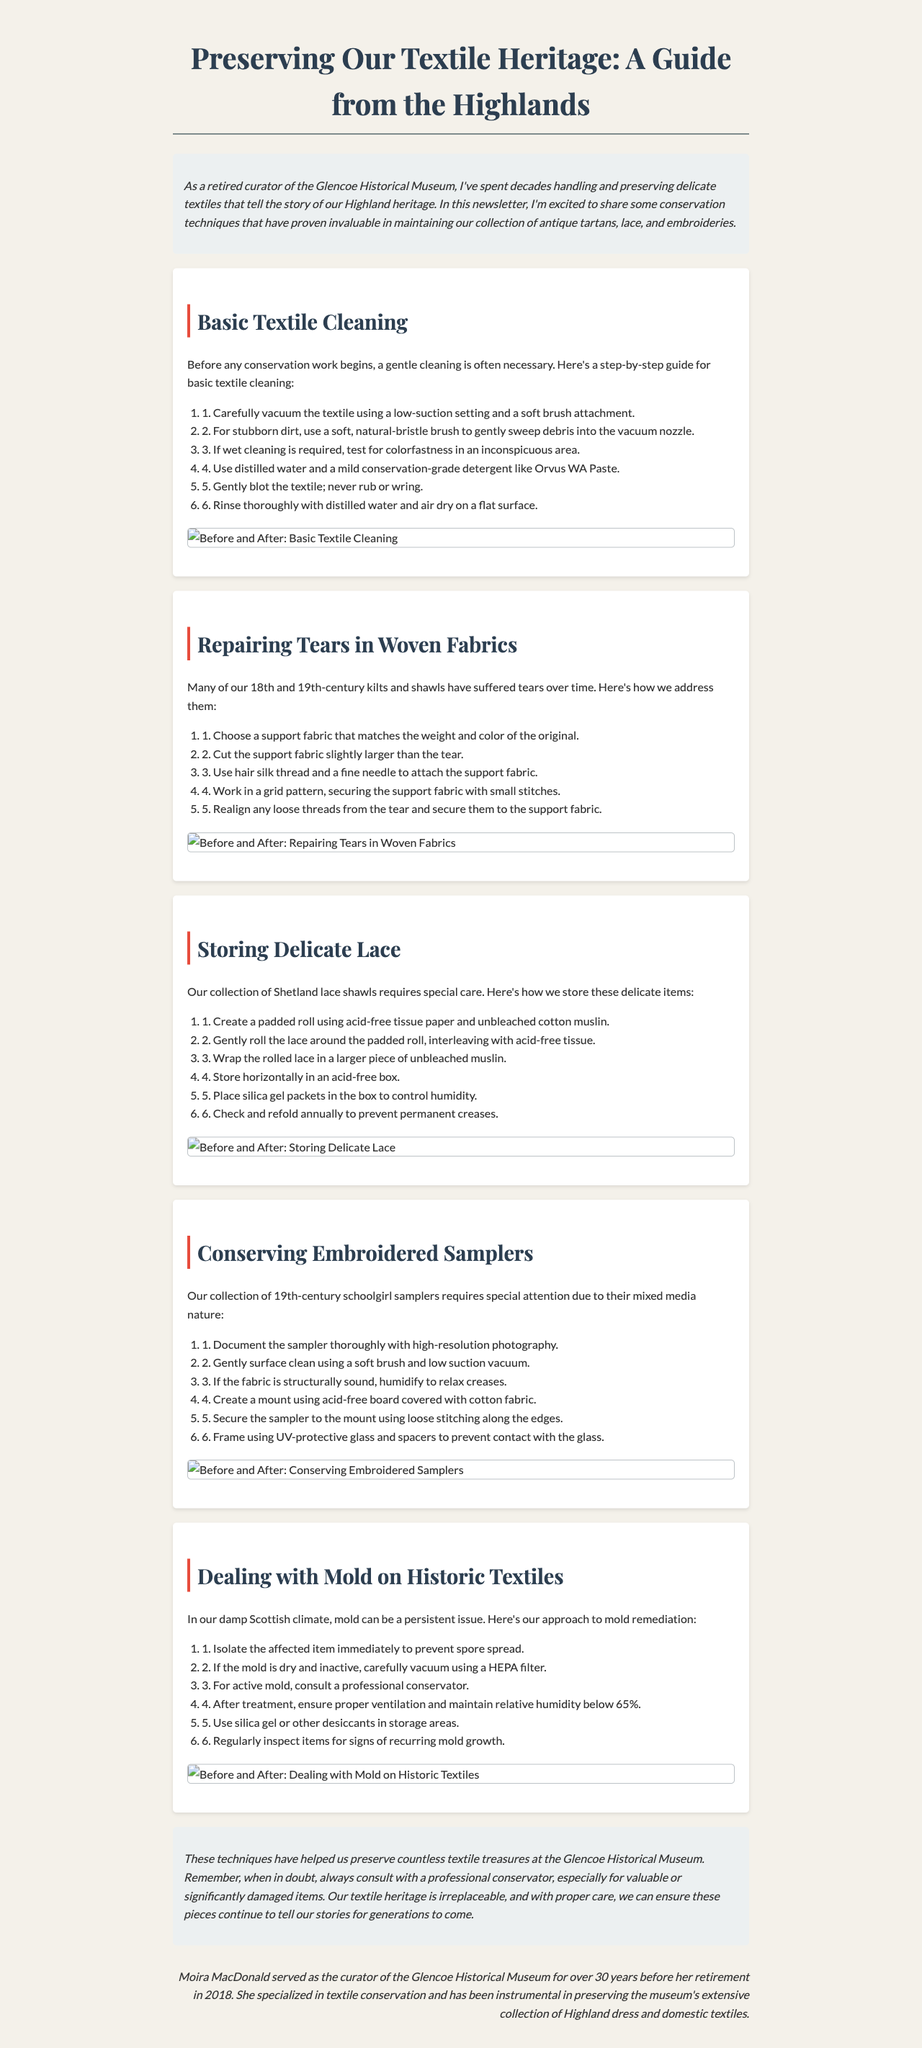What is the title of the newsletter? The title appears prominently at the top of the document, outlining the subject matter.
Answer: Preserving Our Textile Heritage: A Guide from the Highlands Who is the author of the newsletter? At the end of the document, there is a section dedicated to the author, giving their name and background.
Answer: Moira MacDonald What is the first step in basic textile cleaning? Each section lists its conservation steps in order, starting with the first action to take.
Answer: Carefully vacuum the textile using a low-suction setting and a soft brush attachment What fabric is recommended for repairing tears in woven fabrics? The content specifies what type of fabric should be selected during the repair process.
Answer: Support fabric How should delicate lace be stored? The newsletter includes specific steps for the proper storage of delicate lace, detailing the final storage method.
Answer: Store horizontally in an acid-free box What is the humidity level that should be maintained to prevent mold growth? The document advises on maintaining certain conditions to avoid mold issues.
Answer: Below 65% What type of glass is recommended for framing embroidered samplers? Recommendations for framing include the material of the glass to protect the items.
Answer: UV-protective glass How long did Moira MacDonald serve as curator of the museum? The document provides details about the author's tenure, emphasizing their experience.
Answer: Over 30 years 